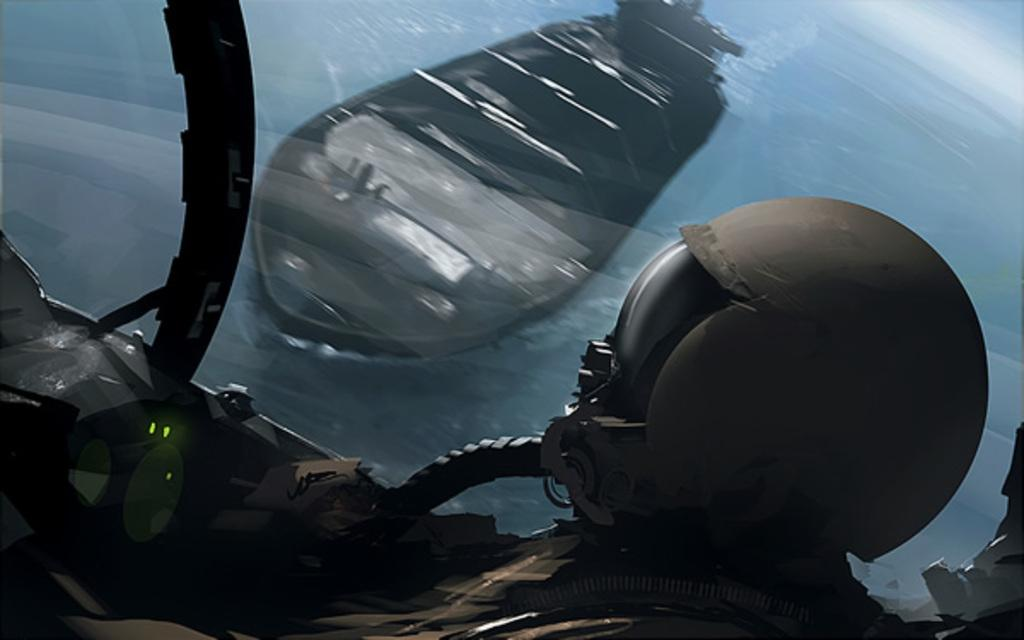What is the person in the image wearing on their head? The person is wearing a helmet in the image. Where is the person located in the image? The person is inside a vehicle. What type of vehicle is the person in? The vehicle resembles an aircraft. Can the person see outside the vehicle? Yes, there is a window in the vehicle. What can be seen through the window? A ship is visible through the window. What is the ship's location in relation to the water? The ship is on water. What type of mark can be seen on the person's underwear in the image? There is no mention of underwear or any marks on them in the image. 